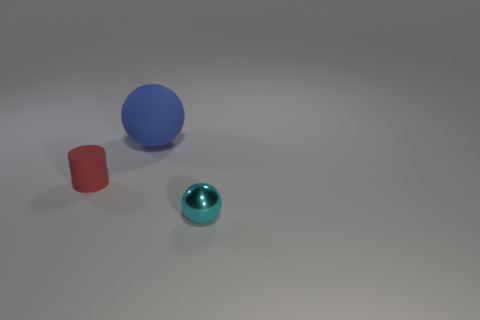There is a small thing in front of the tiny matte thing; is there a small cyan sphere that is behind it?
Your answer should be compact. No. There is a thing that is to the left of the blue matte object; what shape is it?
Give a very brief answer. Cylinder. The ball in front of the small thing behind the cyan metallic thing is what color?
Provide a succinct answer. Cyan. Is the matte sphere the same size as the metallic object?
Provide a succinct answer. No. There is another object that is the same shape as the cyan metallic thing; what material is it?
Your answer should be compact. Rubber. How many brown matte objects are the same size as the rubber cylinder?
Make the answer very short. 0. There is a large thing that is the same material as the cylinder; what color is it?
Ensure brevity in your answer.  Blue. Are there fewer big matte balls than big red metallic blocks?
Give a very brief answer. No. How many blue things are either shiny spheres or large matte balls?
Provide a short and direct response. 1. How many balls are in front of the small red cylinder and on the left side of the shiny object?
Make the answer very short. 0. 